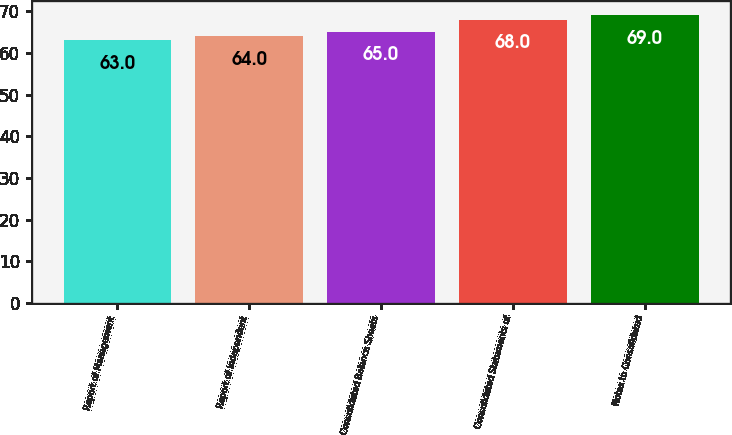Convert chart to OTSL. <chart><loc_0><loc_0><loc_500><loc_500><bar_chart><fcel>Report of Management<fcel>Report of Independent<fcel>Consolidated Balance Sheets<fcel>Consolidated Statements of<fcel>Notes to Consolidated<nl><fcel>63<fcel>64<fcel>65<fcel>68<fcel>69<nl></chart> 